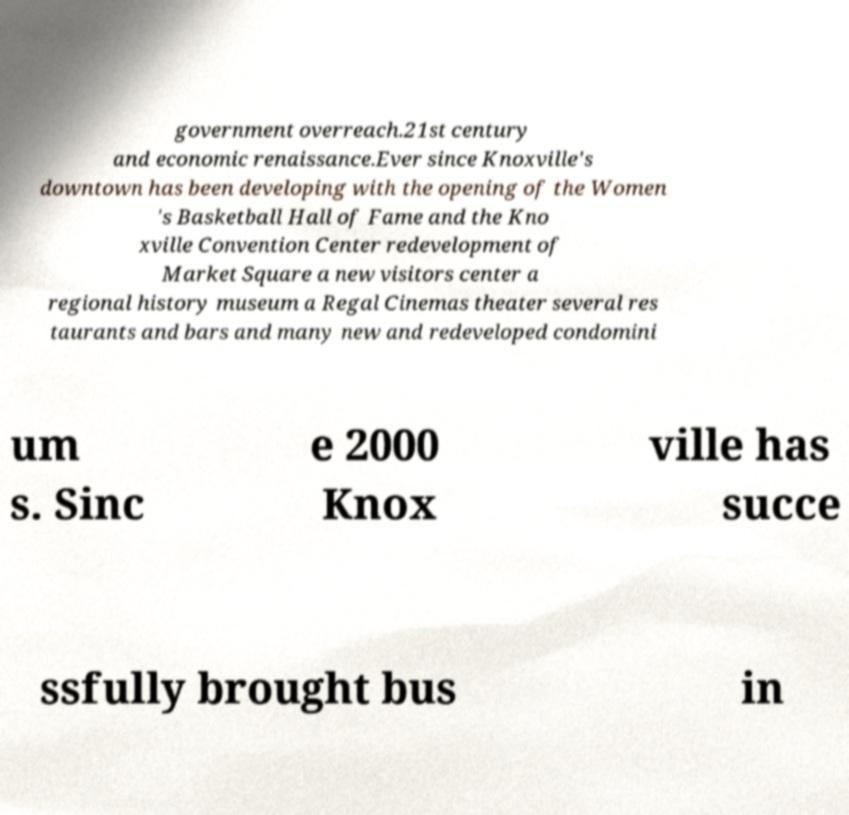For documentation purposes, I need the text within this image transcribed. Could you provide that? government overreach.21st century and economic renaissance.Ever since Knoxville's downtown has been developing with the opening of the Women 's Basketball Hall of Fame and the Kno xville Convention Center redevelopment of Market Square a new visitors center a regional history museum a Regal Cinemas theater several res taurants and bars and many new and redeveloped condomini um s. Sinc e 2000 Knox ville has succe ssfully brought bus in 